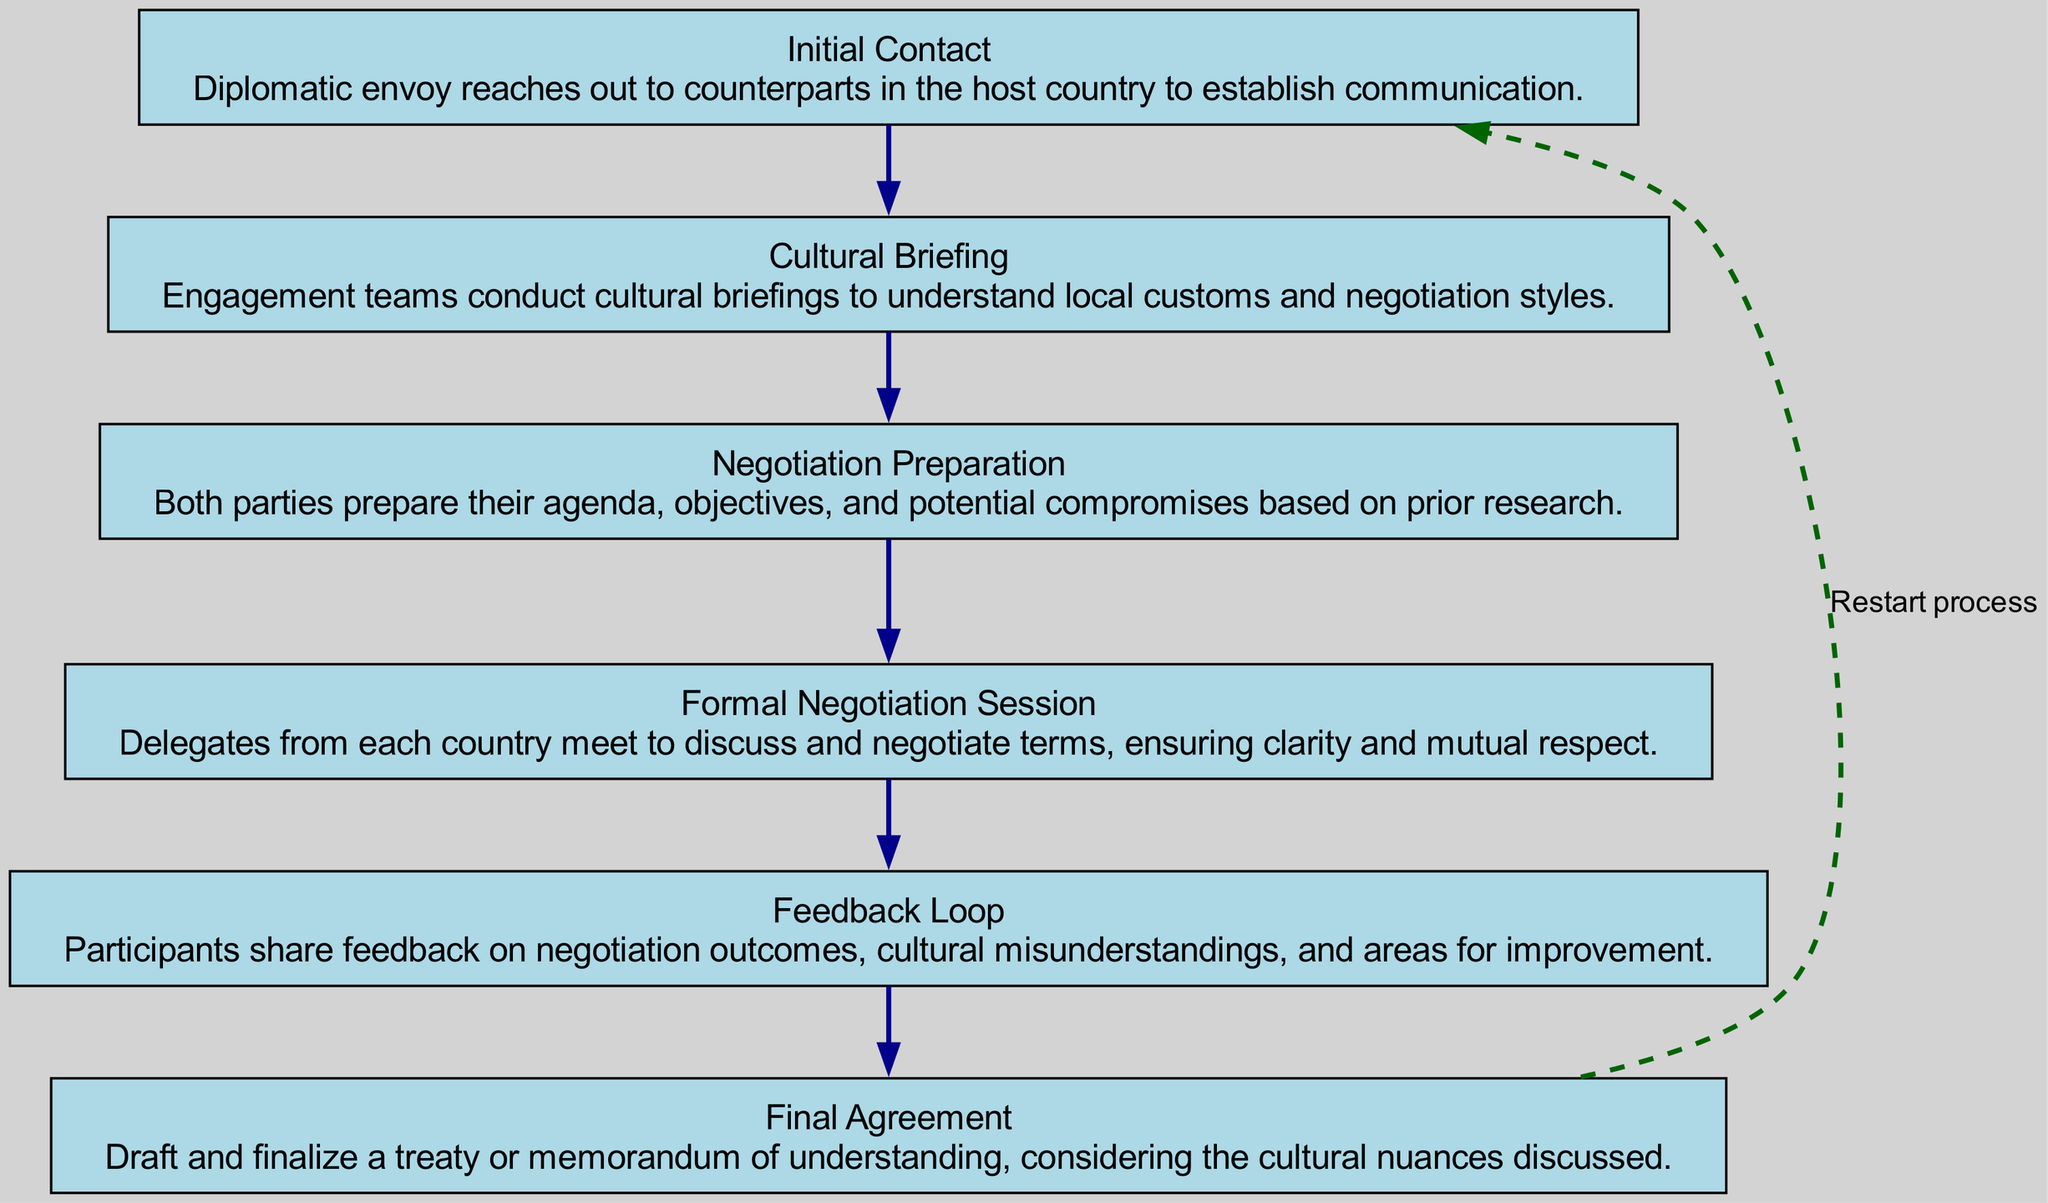What is the first step in the chain of communication? The first step listed in the diagram is "Initial Contact." This is determined by looking at the top of the flow chart, where each step is arranged sequentially.
Answer: Initial Contact How many steps are there in the chain of communication? By counting each distinct step shown in the diagram, one can determine that there are a total of six steps from Initial Contact to Final Agreement.
Answer: 6 What step follows "Cultural Briefing"? After "Cultural Briefing," the next step is "Negotiation Preparation," as the flow chart indicates a direct progression from one step to the next.
Answer: Negotiation Preparation Which step emphasizes cultural understanding? The step that emphasizes cultural understanding is "Cultural Briefing." This is evident from its title and description, which focuses on understanding local customs and negotiation styles.
Answer: Cultural Briefing What action is taken after the "Formal Negotiation Session"? After the "Formal Negotiation Session," the next action that occurs is a "Feedback Loop," as shown in the flow chart where these steps are connected directly in sequence.
Answer: Feedback Loop Is there a connection from "Final Agreement" back to "Initial Contact"? Yes, there is a dashed edge labeled "Restart process" that shows a connection from "Final Agreement" back to "Initial Contact," indicating a cyclical process in the communication chain.
Answer: Yes What is the main purpose of the "Feedback Loop"? The main purpose of the "Feedback Loop" is to share feedback on negotiation outcomes, cultural misunderstandings, and areas for improvement, as stated in the description for that step.
Answer: Share feedback What does the final step involve? The final step, "Final Agreement," involves drafting and finalizing a treaty or memorandum of understanding, which is highlighted in its description within the flow chart.
Answer: Draft and finalize a treaty Which step is connected to the feedback process? The step connected to the feedback process is "Feedback Loop," as it specifically focuses on participants sharing their feedback regarding the negotiations.
Answer: Feedback Loop 